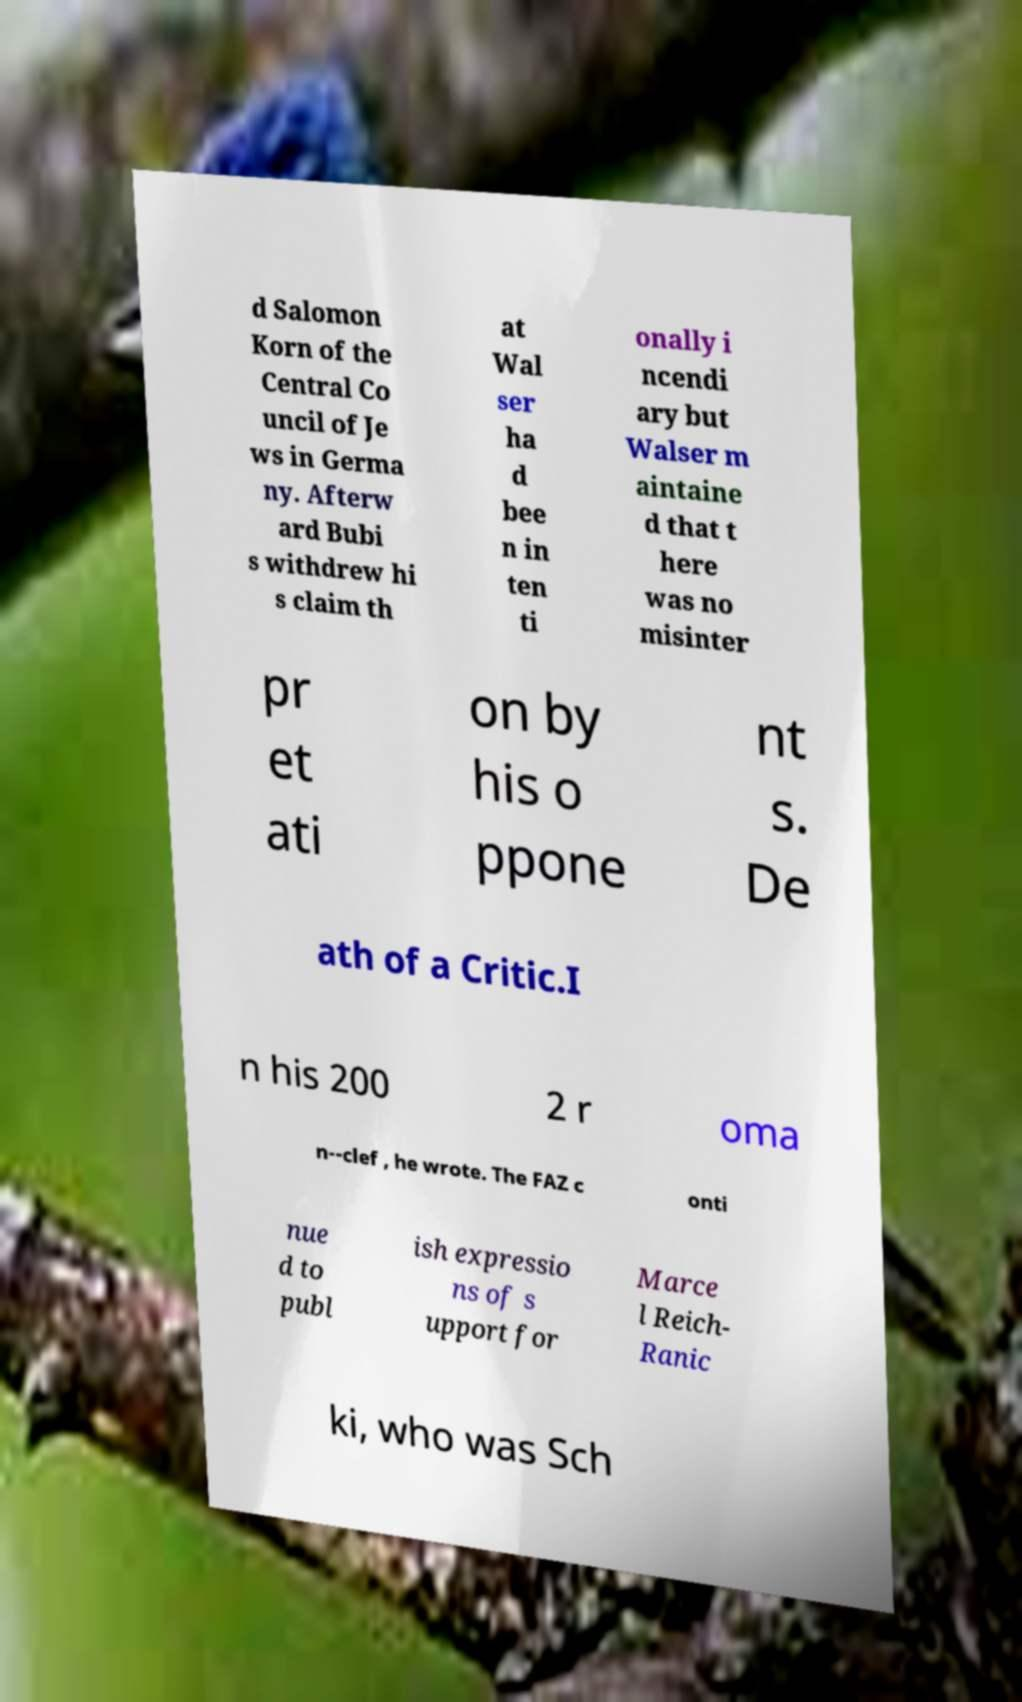Could you extract and type out the text from this image? d Salomon Korn of the Central Co uncil of Je ws in Germa ny. Afterw ard Bubi s withdrew hi s claim th at Wal ser ha d bee n in ten ti onally i ncendi ary but Walser m aintaine d that t here was no misinter pr et ati on by his o ppone nt s. De ath of a Critic.I n his 200 2 r oma n--clef , he wrote. The FAZ c onti nue d to publ ish expressio ns of s upport for Marce l Reich- Ranic ki, who was Sch 